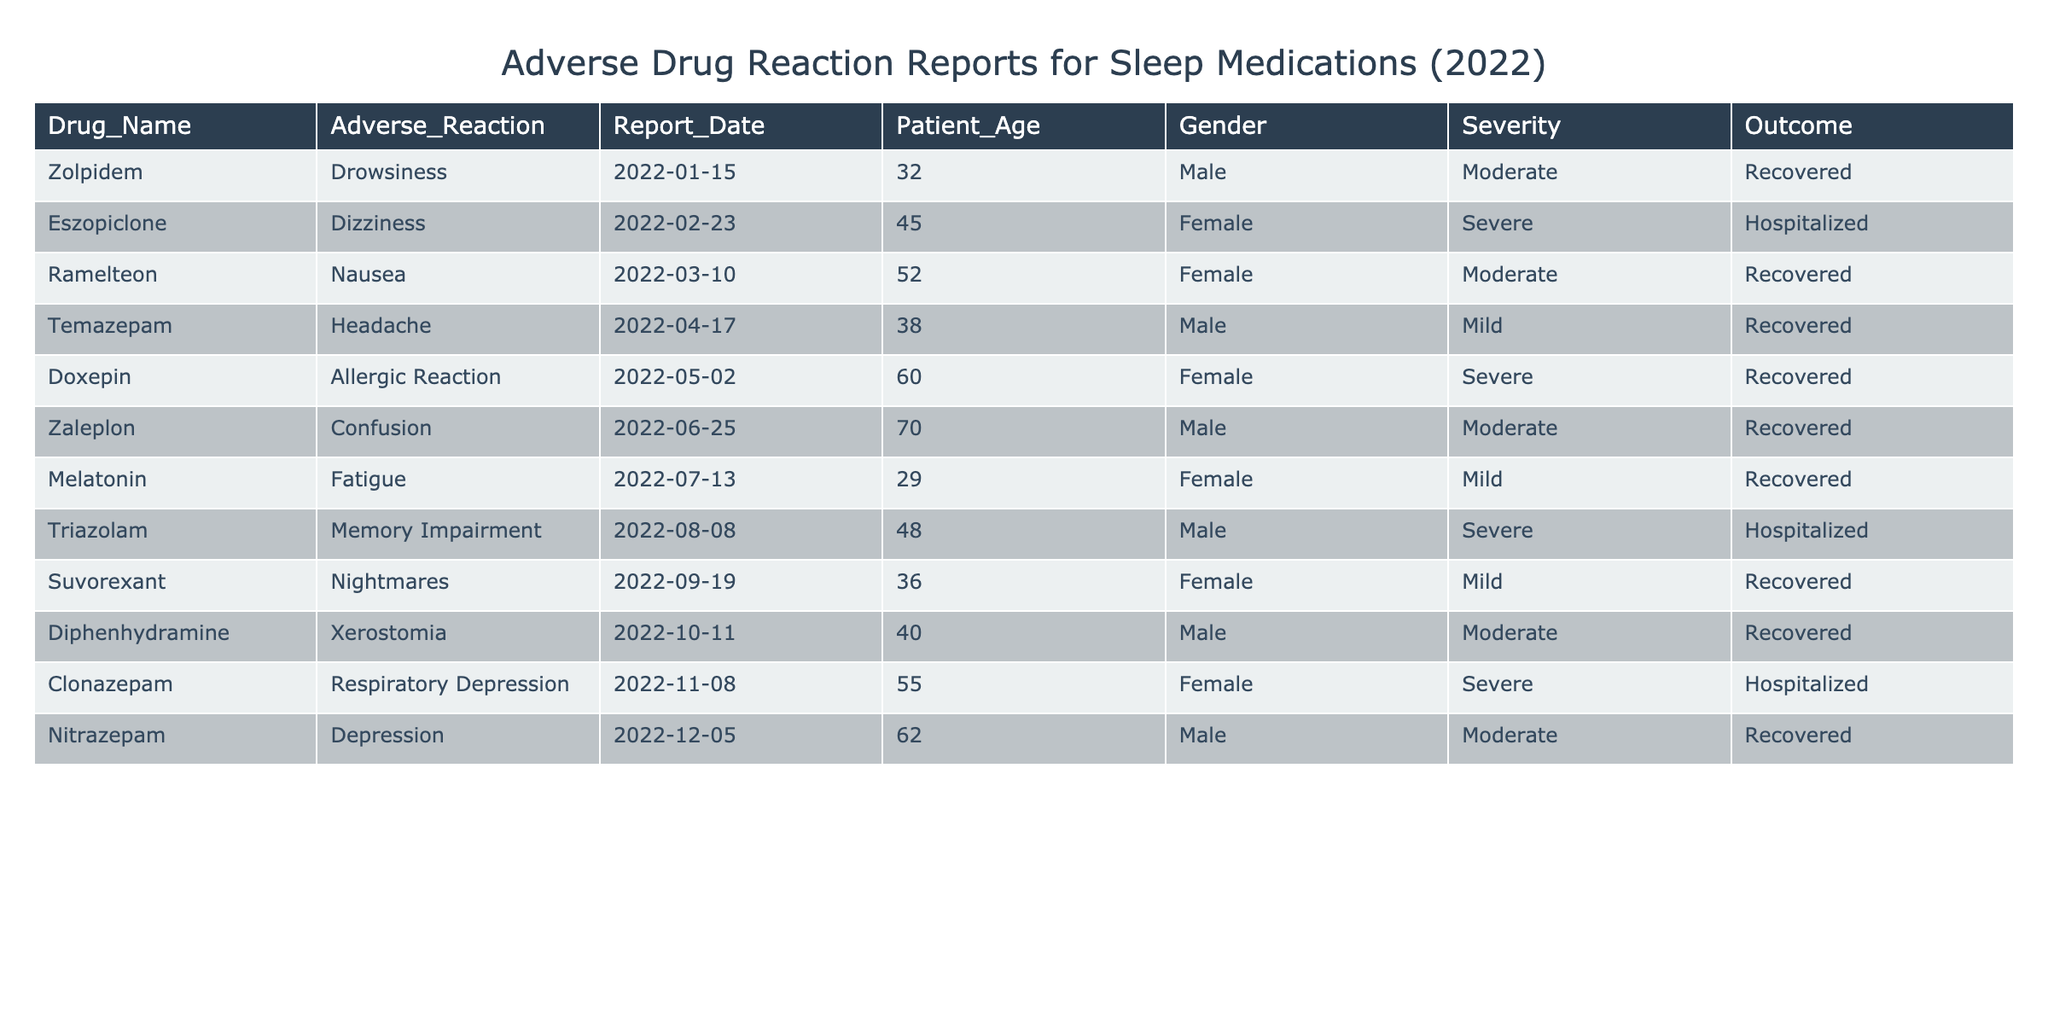What is the most severe adverse reaction reported for sleep medications? The table lists multiple adverse reactions, and to find the most severe one, we check the Severity column. The adverse reactions with "Severe" severity are Eszopiclone (Dizziness), Doxepin (Allergic Reaction), Triazolam (Memory Impairment), and Clonazepam (Respiratory Depression). Since all are categorized as severe, the answer is the name of the drugs with this severity.
Answer: Eszopiclone, Doxepin, Triazolam, Clonazepam How many patients aged over 50 reported adverse reactions? We can filter the Patient_Age column to find patients older than 50 years. From the data, the patients aged 60 and 62 (Doxepin and Nitrazepam) reported adverse reactions. So, there are two patients over 50.
Answer: 2 Did any male patients experience severe adverse reactions? We check the Gender column for "Male" and the Severity column for "Severe." The table shows Triazolam (Male) and Clonazepam (Female) as having severe reactions. Therefore, no male patients reported severe adverse reactions.
Answer: No What is the total number of reports for adverse reactions classified as 'Moderate'? We need to count the number of entries in the Severity column marked as "Moderate." Inspecting the table, we find that there are five instances: Zolpidem, Ramelteon, Zaleplon, Diphenhydramine, and Nitrazepam. By counting these, we determine the total number of moderate reports.
Answer: 5 Among the reported outcomes, how many patients were hospitalized? By looking at the Outcome column, we identify the entries that state "Hospitalized." The medications leading to hospitalization are Eszopiclone and Triazolam, marking a total of two patients who were hospitalized due to adverse reactions.
Answer: 2 Is there any report of an allergic reaction to Zolpidem? The table lists an Adverse Reaction for Zolpidem as Drowsiness, not an allergic reaction. Since the adverse reaction associated with Zolpidem does not match the query, the answer is no.
Answer: No What percentage of the reported reactions were classified as mild? To calculate this, we identify the instances of "Mild" in the Severity column, which are Melatonin and Suvorexant totaling 2 mild reactions. The total number of reported adverse reactions is 12. Thus, to find the percentage, we take (2/12) * 100 which results in approximately 16.67%.
Answer: 16.67% Which adverse reaction had the oldest patient and what was the outcome? We need to identify the row with the highest age in the Patient_Age column. The oldest patient is associated with Zaleplon at age 70. This patient had "Confusion" as the adverse reaction and the outcome was "Recovered."
Answer: 70 years, Confusion, Recovered 